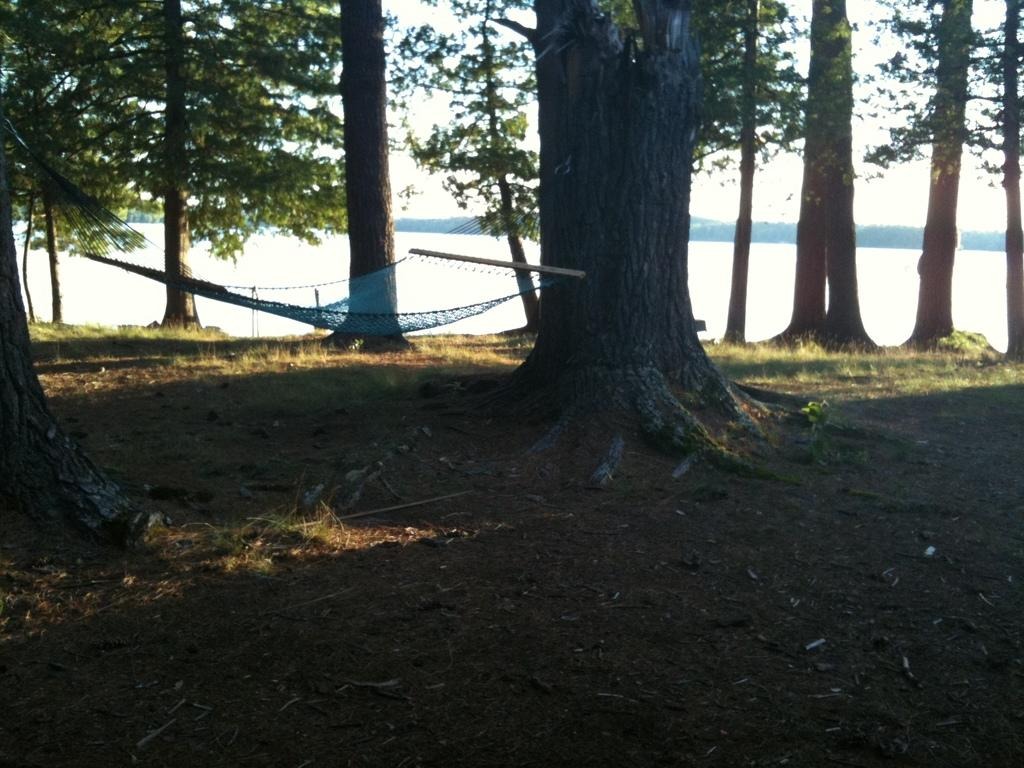What is the main object in the image? There is a hammock in the image. What type of vegetation is present in the image? There are trees in the image. What can be seen at the bottom of the image? The land is visible at the bottom of the image. What type of ground cover is on the land? There is grass on the land. What is visible in the background of the image? The background of the image includes the sea. Can you see a crown on the trees in the image? There is no crown present on the trees in the image. Is there a snake visible in the wilderness area of the image? There is no wilderness area or snake visible in the image. 